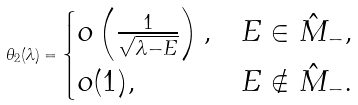Convert formula to latex. <formula><loc_0><loc_0><loc_500><loc_500>\theta _ { 2 } ( \lambda ) = \begin{cases} o \left ( \frac { 1 } { \sqrt { \lambda - E } } \right ) , & E \in \hat { M } _ { - } , \\ o ( 1 ) , & E \notin \hat { M } _ { - } . \end{cases}</formula> 